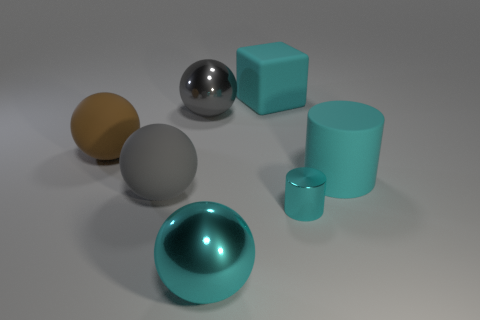Subtract 1 spheres. How many spheres are left? 3 Add 1 big blocks. How many objects exist? 8 Subtract all balls. How many objects are left? 3 Subtract all gray metal cylinders. Subtract all large brown matte balls. How many objects are left? 6 Add 7 large gray matte objects. How many large gray matte objects are left? 8 Add 4 purple rubber blocks. How many purple rubber blocks exist? 4 Subtract 0 purple cubes. How many objects are left? 7 